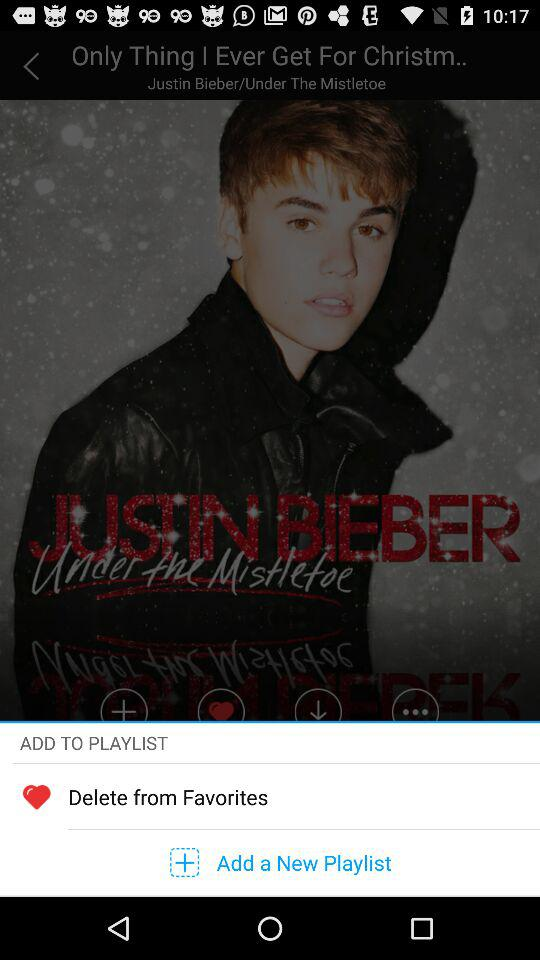Who is the singer of the song? The singer is Justin Bieber. 